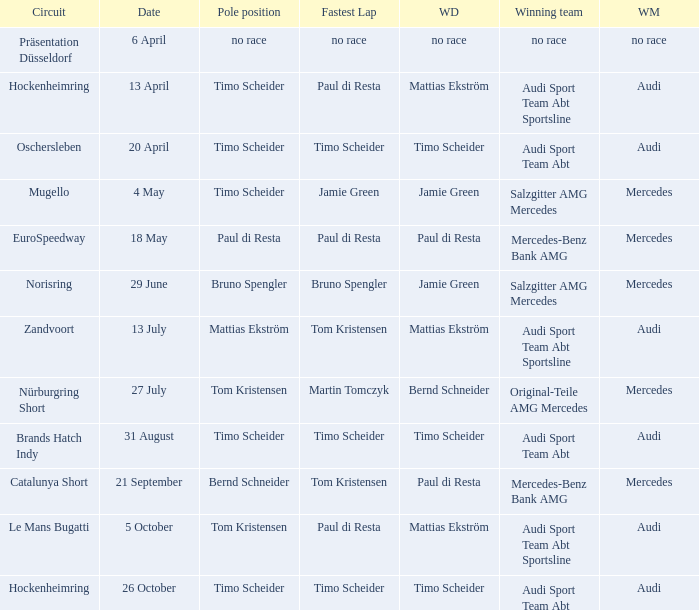What is the winning team of the race on 31 August with Audi as the winning manufacturer and Timo Scheider as the winning driver? Audi Sport Team Abt. 